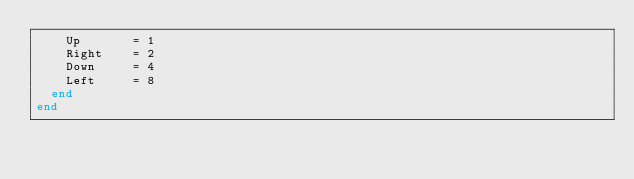<code> <loc_0><loc_0><loc_500><loc_500><_Crystal_>    Up       = 1
    Right    = 2
    Down     = 4
    Left     = 8
  end
end
</code> 